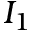Convert formula to latex. <formula><loc_0><loc_0><loc_500><loc_500>I _ { 1 }</formula> 